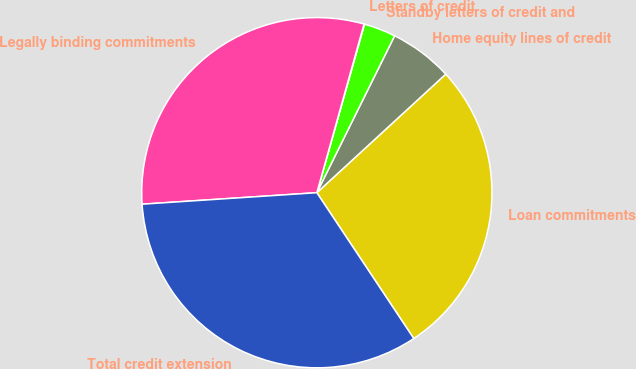Convert chart. <chart><loc_0><loc_0><loc_500><loc_500><pie_chart><fcel>Loan commitments<fcel>Home equity lines of credit<fcel>Standby letters of credit and<fcel>Letters of credit<fcel>Legally binding commitments<fcel>Total credit extension<nl><fcel>27.5%<fcel>5.84%<fcel>2.94%<fcel>0.04%<fcel>30.39%<fcel>33.29%<nl></chart> 